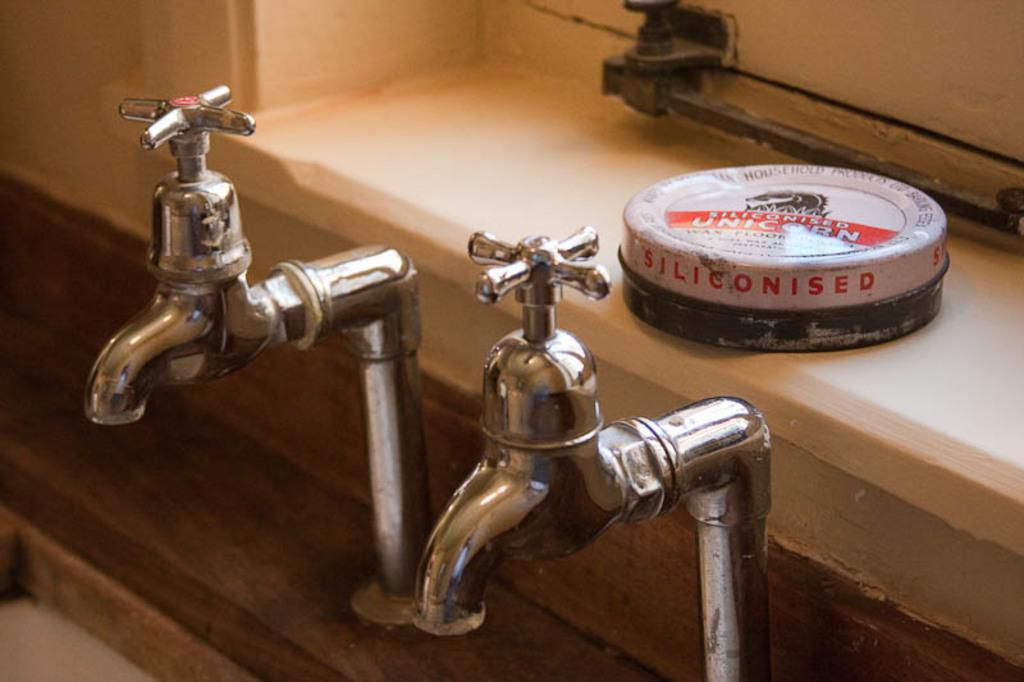Please provide a concise description of this image. Here we can see two taps and there is a box on the platform. 